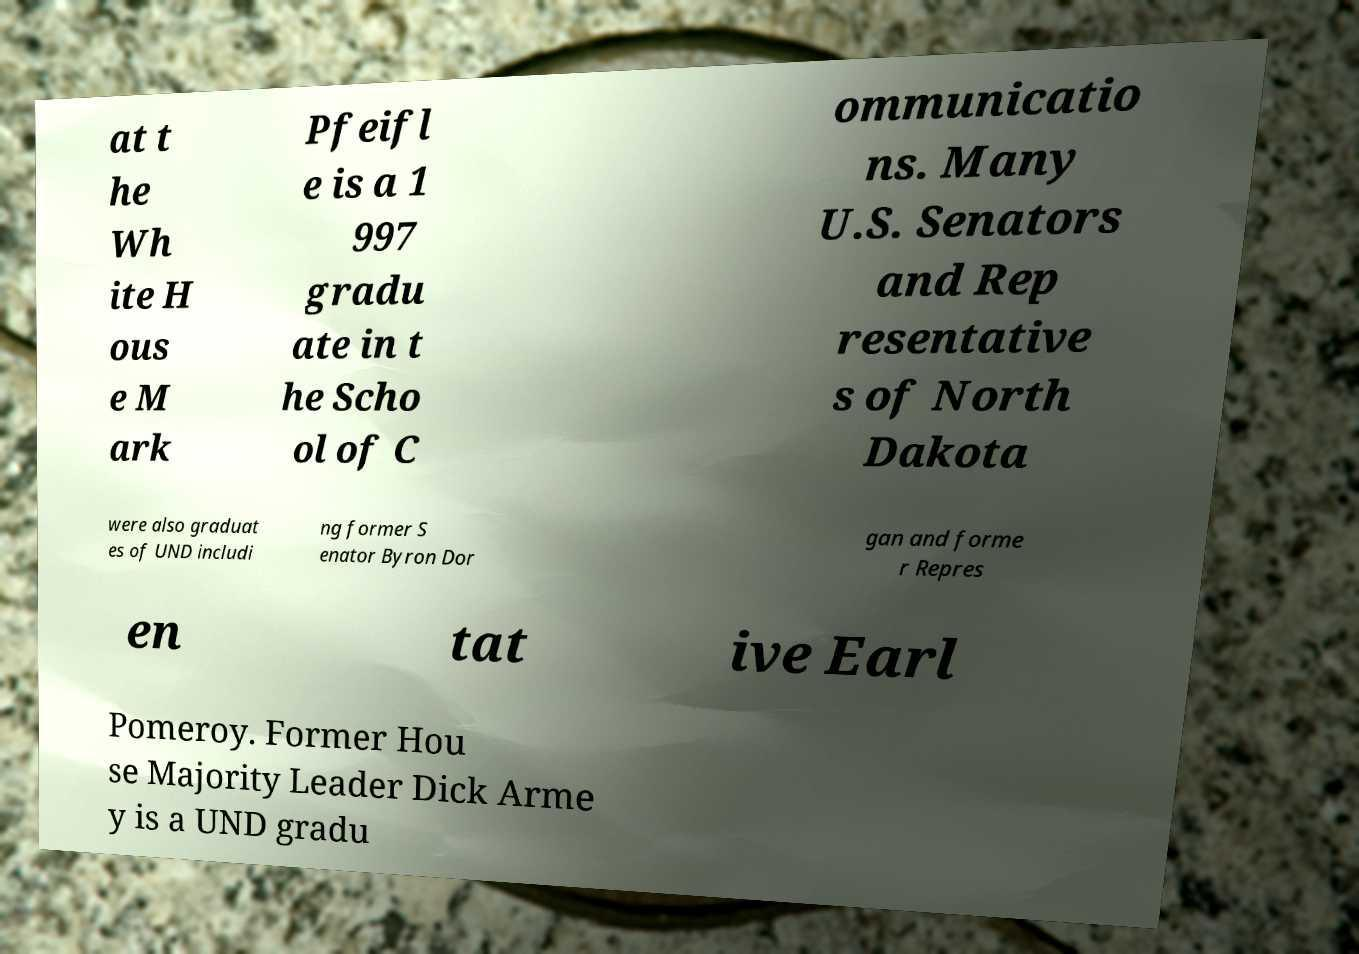Can you accurately transcribe the text from the provided image for me? at t he Wh ite H ous e M ark Pfeifl e is a 1 997 gradu ate in t he Scho ol of C ommunicatio ns. Many U.S. Senators and Rep resentative s of North Dakota were also graduat es of UND includi ng former S enator Byron Dor gan and forme r Repres en tat ive Earl Pomeroy. Former Hou se Majority Leader Dick Arme y is a UND gradu 